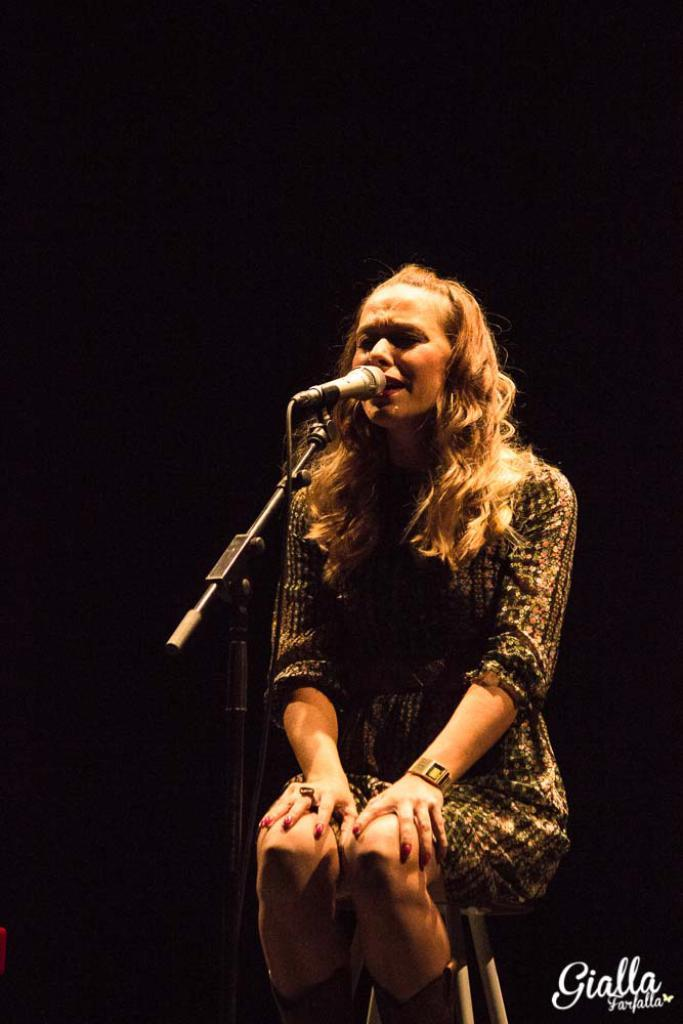Who is the main subject in the picture? There is a woman in the center of the picture. What is the woman doing in the image? The woman is sitting on a stool and singing into a microphone. What can be seen in the background of the image? The background of the image is dark. Is there any text present in the image? Yes, there is text at the bottom towards the right side of the image. What type of animal can be seen crossing the bridge in the image? A: There is no animal or bridge present in the image; it features a woman singing into a microphone with a dark background and text at the bottom. What kind of vegetable is being used as a prop by the woman in the image? There is no vegetable present in the image; the woman is singing into a microphone while sitting on a stool. 